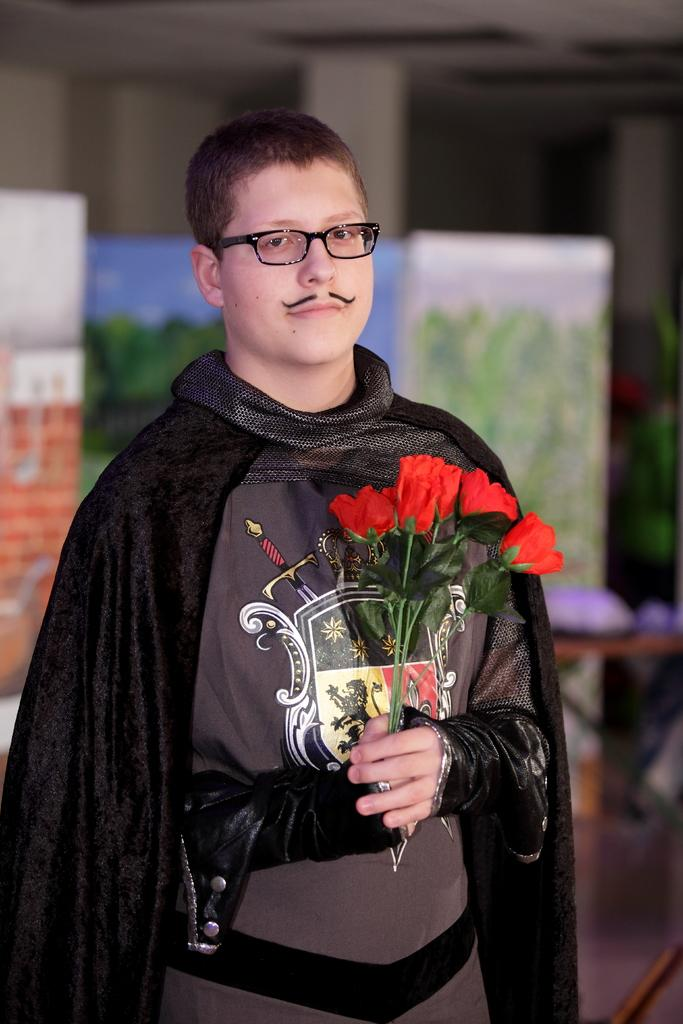Who is the main subject in the picture? There is a boy in the picture. Where is the boy positioned in the image? The boy is standing in the center of the image. What is the boy holding in his hands? The boy is holding flowers in his hands. What type of glove is the boy wearing in the image? There is no glove visible in the image; the boy is holding flowers in his hands. How many birds are in the flock that is flying above the boy in the image? There is no flock of birds present in the image; the boy is holding flowers in his hands. 